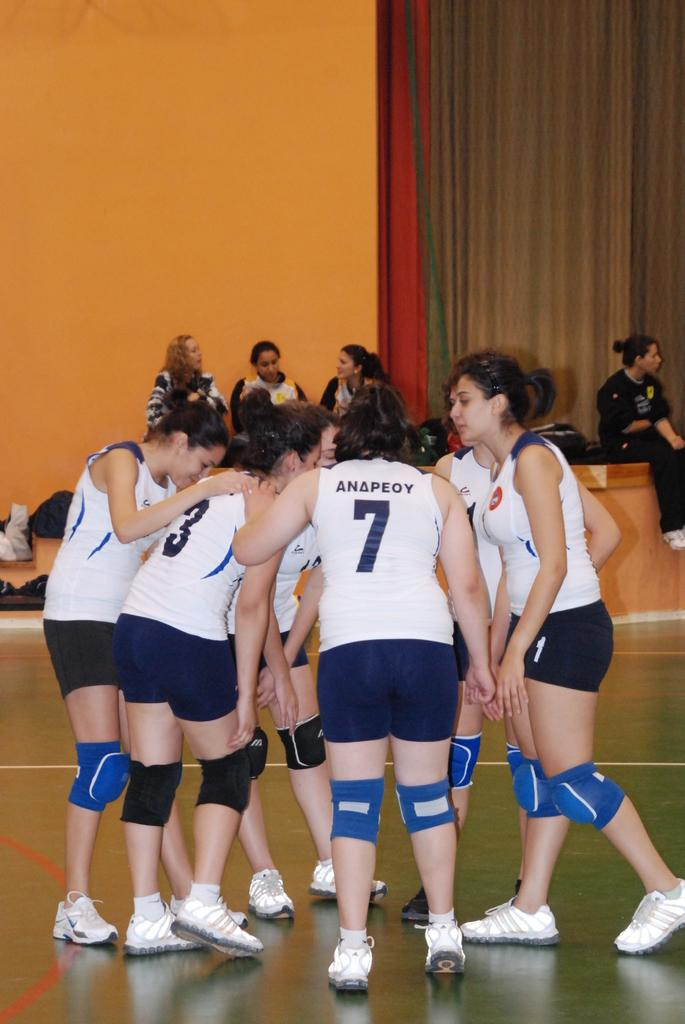<image>
Give a short and clear explanation of the subsequent image. Several female athletes are in a huddle with one having the number 7 on her back. 